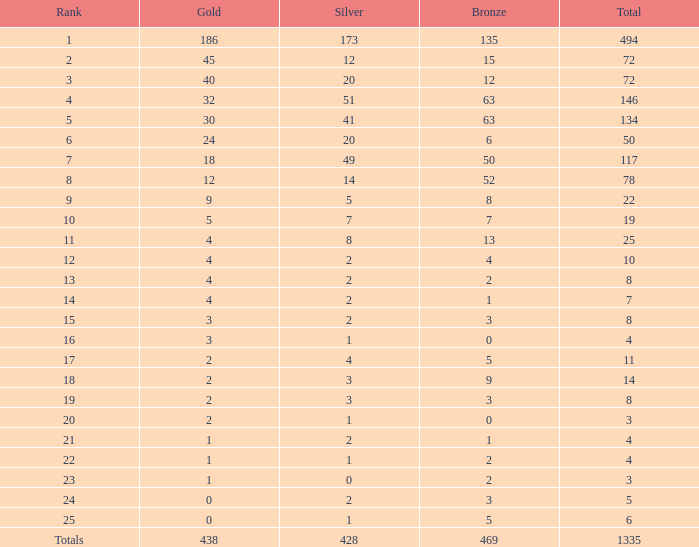What is the number of bronze medals when the total medals were 78 and there were less than 12 golds? None. 